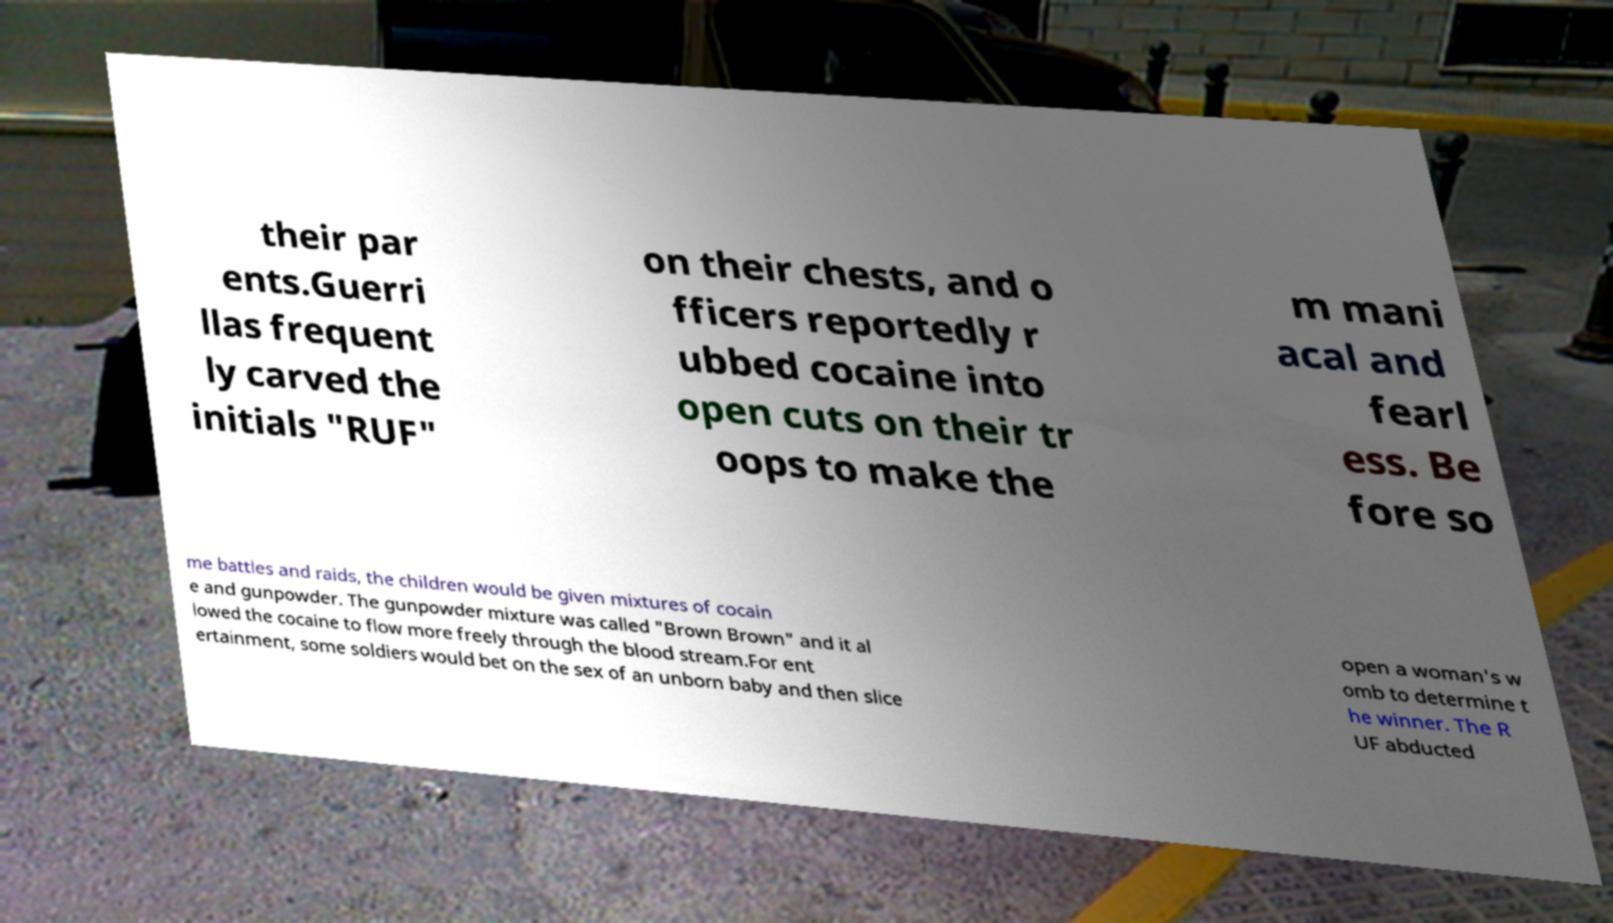For documentation purposes, I need the text within this image transcribed. Could you provide that? their par ents.Guerri llas frequent ly carved the initials "RUF" on their chests, and o fficers reportedly r ubbed cocaine into open cuts on their tr oops to make the m mani acal and fearl ess. Be fore so me battles and raids, the children would be given mixtures of cocain e and gunpowder. The gunpowder mixture was called "Brown Brown" and it al lowed the cocaine to flow more freely through the blood stream.For ent ertainment, some soldiers would bet on the sex of an unborn baby and then slice open a woman's w omb to determine t he winner. The R UF abducted 